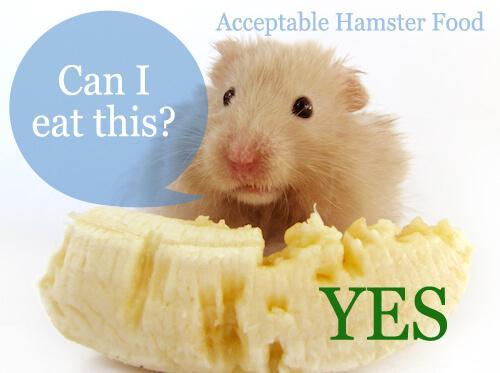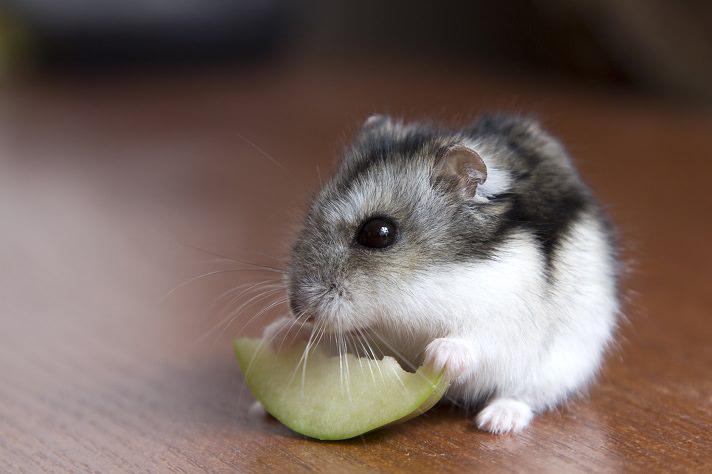The first image is the image on the left, the second image is the image on the right. Examine the images to the left and right. Is the description "The rodent in the image on the right has a piece of broccoli in front of it." accurate? Answer yes or no. No. The first image is the image on the left, the second image is the image on the right. Evaluate the accuracy of this statement regarding the images: "A bright green broccoli floret is in front of a pet rodent.". Is it true? Answer yes or no. No. 